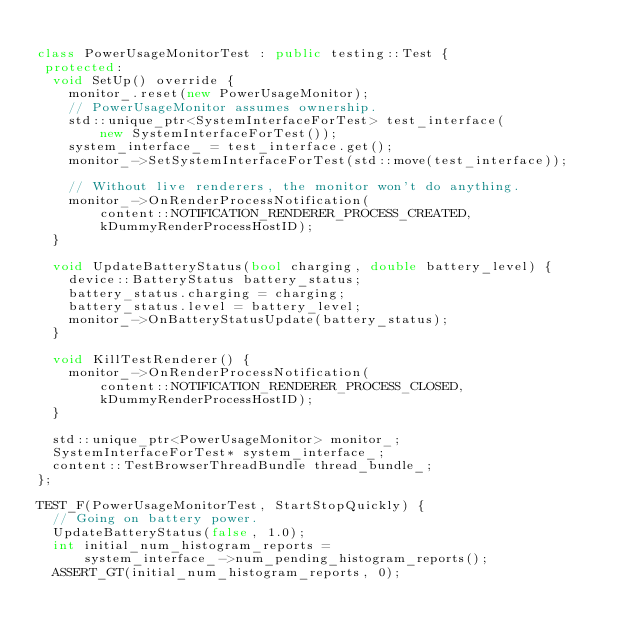Convert code to text. <code><loc_0><loc_0><loc_500><loc_500><_C++_>
class PowerUsageMonitorTest : public testing::Test {
 protected:
  void SetUp() override {
    monitor_.reset(new PowerUsageMonitor);
    // PowerUsageMonitor assumes ownership.
    std::unique_ptr<SystemInterfaceForTest> test_interface(
        new SystemInterfaceForTest());
    system_interface_ = test_interface.get();
    monitor_->SetSystemInterfaceForTest(std::move(test_interface));

    // Without live renderers, the monitor won't do anything.
    monitor_->OnRenderProcessNotification(
        content::NOTIFICATION_RENDERER_PROCESS_CREATED,
        kDummyRenderProcessHostID);
  }

  void UpdateBatteryStatus(bool charging, double battery_level) {
    device::BatteryStatus battery_status;
    battery_status.charging = charging;
    battery_status.level = battery_level;
    monitor_->OnBatteryStatusUpdate(battery_status);
  }

  void KillTestRenderer() {
    monitor_->OnRenderProcessNotification(
        content::NOTIFICATION_RENDERER_PROCESS_CLOSED,
        kDummyRenderProcessHostID);
  }

  std::unique_ptr<PowerUsageMonitor> monitor_;
  SystemInterfaceForTest* system_interface_;
  content::TestBrowserThreadBundle thread_bundle_;
};

TEST_F(PowerUsageMonitorTest, StartStopQuickly) {
  // Going on battery power.
  UpdateBatteryStatus(false, 1.0);
  int initial_num_histogram_reports =
      system_interface_->num_pending_histogram_reports();
  ASSERT_GT(initial_num_histogram_reports, 0);
</code> 